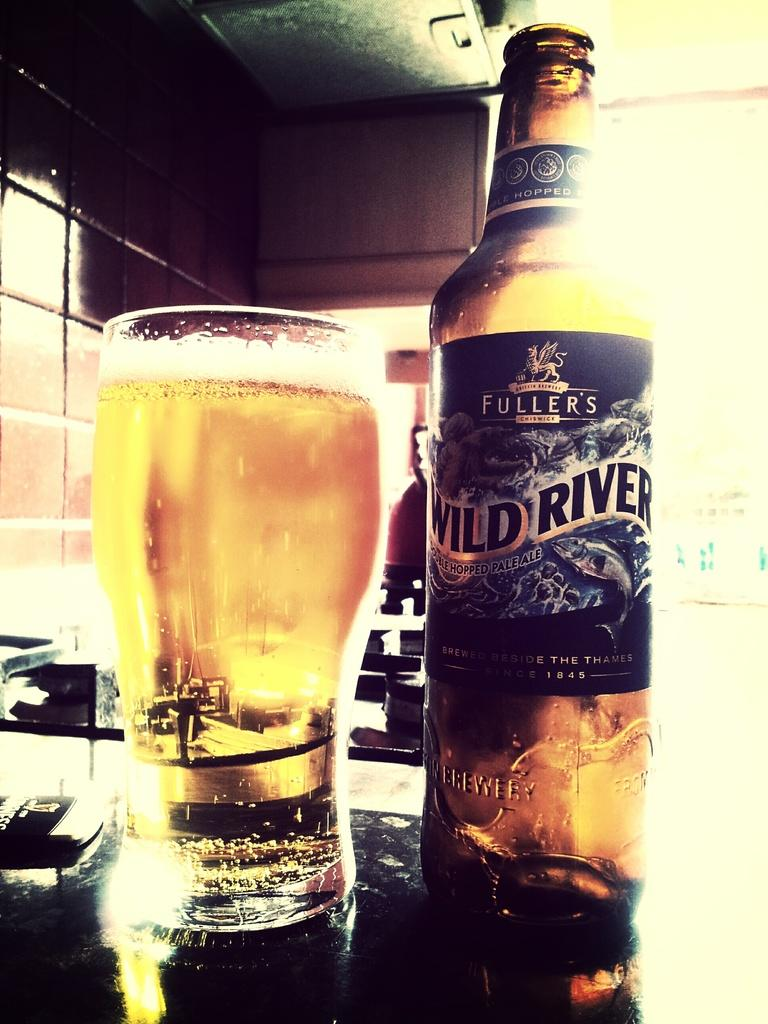<image>
Provide a brief description of the given image. A beer bottle and full glass of Wild River. 